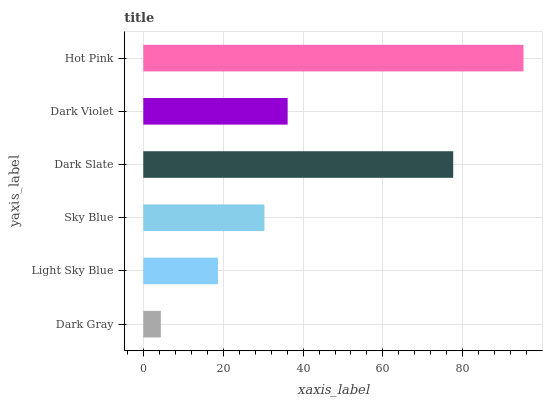Is Dark Gray the minimum?
Answer yes or no. Yes. Is Hot Pink the maximum?
Answer yes or no. Yes. Is Light Sky Blue the minimum?
Answer yes or no. No. Is Light Sky Blue the maximum?
Answer yes or no. No. Is Light Sky Blue greater than Dark Gray?
Answer yes or no. Yes. Is Dark Gray less than Light Sky Blue?
Answer yes or no. Yes. Is Dark Gray greater than Light Sky Blue?
Answer yes or no. No. Is Light Sky Blue less than Dark Gray?
Answer yes or no. No. Is Dark Violet the high median?
Answer yes or no. Yes. Is Sky Blue the low median?
Answer yes or no. Yes. Is Light Sky Blue the high median?
Answer yes or no. No. Is Hot Pink the low median?
Answer yes or no. No. 